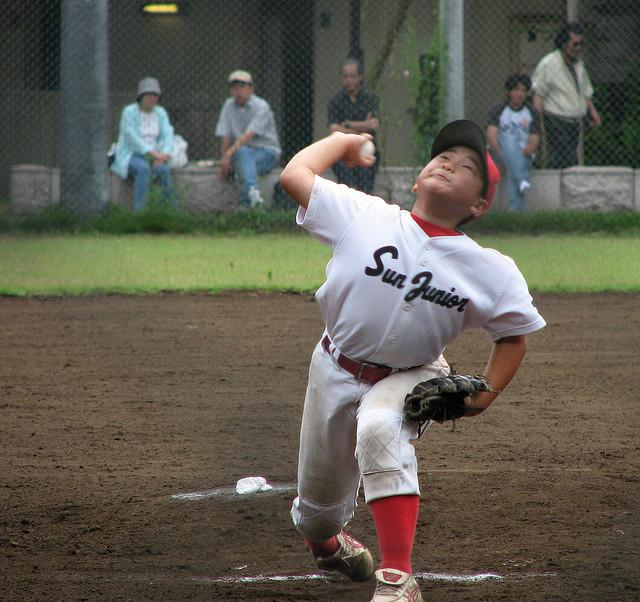Where in the world is this being played? Please explain your reasoning. asia. The man is asian 